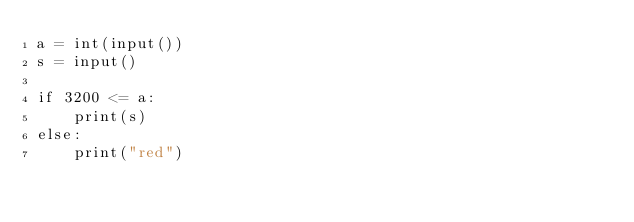Convert code to text. <code><loc_0><loc_0><loc_500><loc_500><_Python_>a = int(input())
s = input()

if 3200 <= a:
    print(s)
else:
    print("red")</code> 